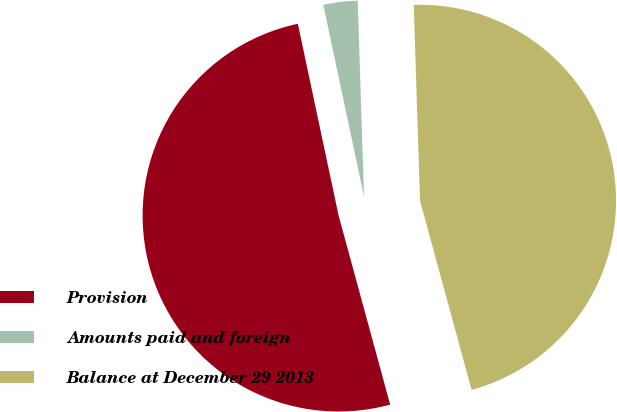<chart> <loc_0><loc_0><loc_500><loc_500><pie_chart><fcel>Provision<fcel>Amounts paid and foreign<fcel>Balance at December 29 2013<nl><fcel>50.91%<fcel>2.82%<fcel>46.28%<nl></chart> 